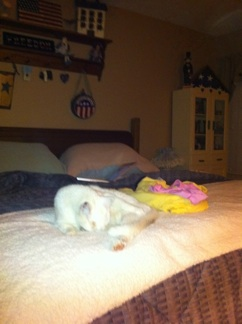Describe a realistic scenario involving the cat in this room. A realistic scenario would be the cat taking a nap in the late afternoon on the bed. After a long day of climbing around the room, exploring the shelves, and possibly playing with the colorful toy, it finds a comfortable spot on the bed and curls up to rest. The soft lighting in the room casts a warm glow, making the environment peaceful and perfect for a cat nap. 